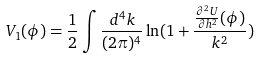<formula> <loc_0><loc_0><loc_500><loc_500>V _ { 1 } ( \phi ) = \frac { 1 } { 2 } \int \frac { d ^ { 4 } k } { ( 2 \pi ) ^ { 4 } } \ln ( 1 + \frac { \frac { \partial ^ { 2 } U } { \partial h ^ { 2 } } ( \phi ) } { k ^ { 2 } } )</formula> 